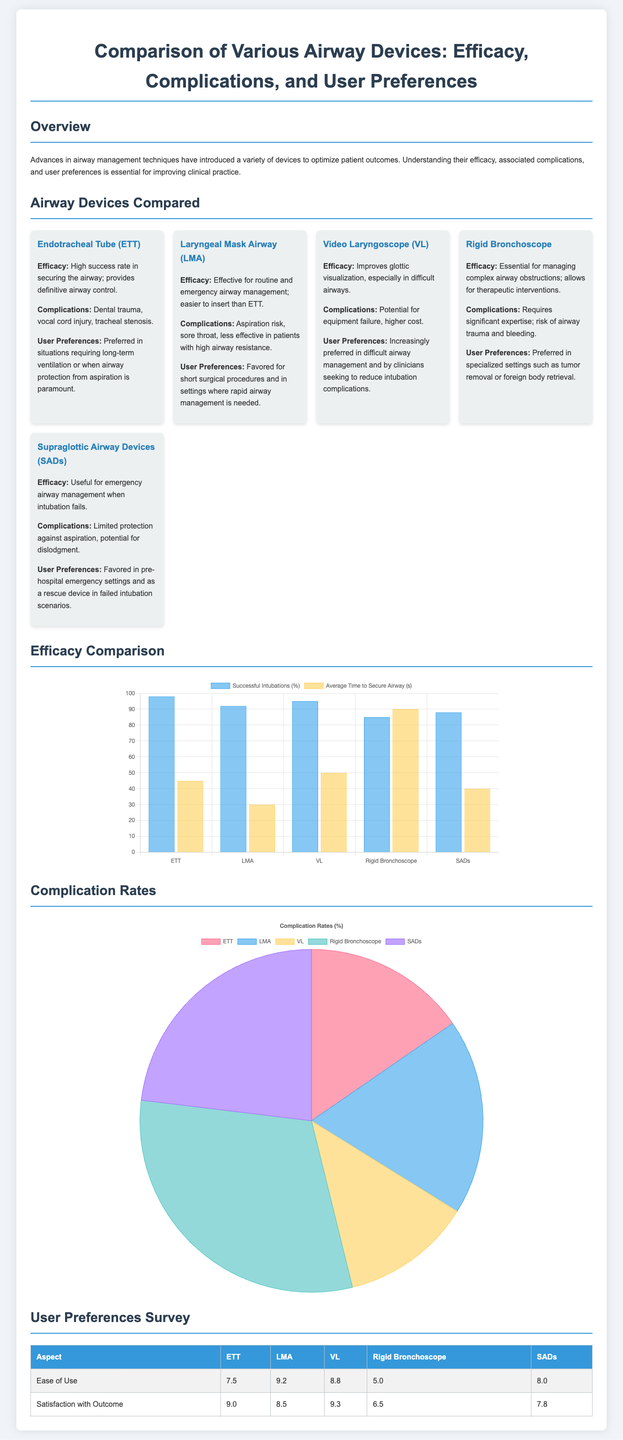What is the success rate of the Endotracheal Tube (ETT)? The success rate of the Endotracheal Tube (ETT) is indicated in the efficacy chart as 98%.
Answer: 98% What device has the highest rating for "Satisfaction with Outcome"? The table regarding user preferences indicates that the Video Laryngoscope (VL) has the highest rating, which is 9.3.
Answer: 9.3 Which airway device is preferred for short surgical procedures? The text under Laryngeal Mask Airway (LMA) states that it is favored for short surgical procedures.
Answer: LMA What is the average time to secure an airway with a Laryngeal Mask Airway (LMA)? The average time to secure an airway with a Laryngeal Mask Airway (LMA) is displayed in the efficacy chart as 30 seconds.
Answer: 30 What percentage of complications is associated with the Rigid Bronchoscope? The pie chart for complication rates shows that the Rigid Bronchoscope has a complication percentage of 20%.
Answer: 20% Which device has the lowest ease of use rating? The user preferences table shows that the Rigid Bronchoscope has the lowest ease of use rating, which is 5.0.
Answer: 5.0 What aspect received a score of 12% in complications? The pie chart indicates that the Laryngeal Mask Airway (LMA) has a complication rate of 12%.
Answer: 12% Which airway device is increasingly preferred in difficult airway management? The text under Video Laryngoscope (VL) states it is increasingly preferred in difficult airway management.
Answer: VL What is the maximum successful intubation percentage among the devices? The efficacy chart reveals that the maximum successful intubation percentage is for ETT at 98%.
Answer: 98% 